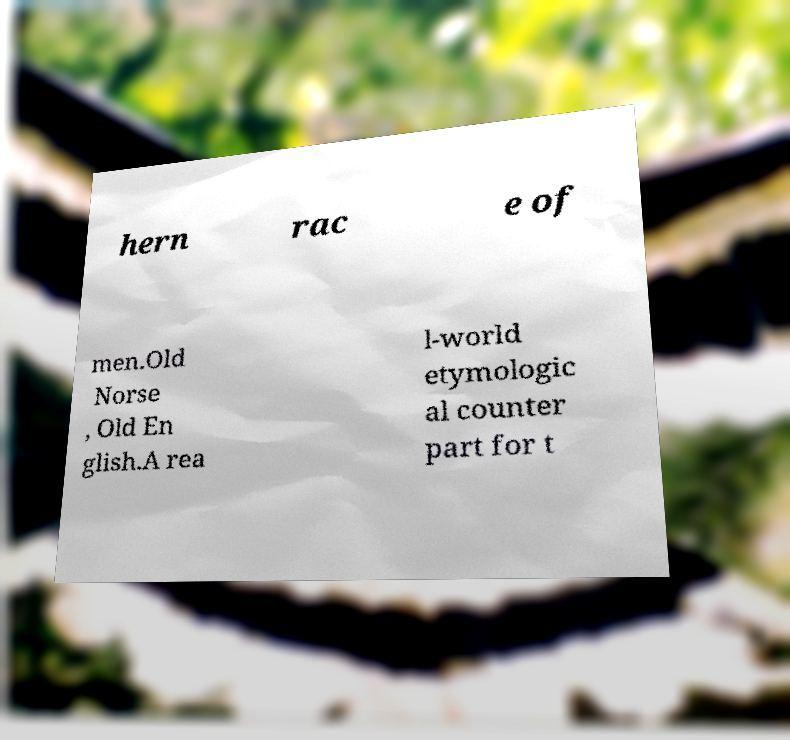Can you read and provide the text displayed in the image?This photo seems to have some interesting text. Can you extract and type it out for me? hern rac e of men.Old Norse , Old En glish.A rea l-world etymologic al counter part for t 